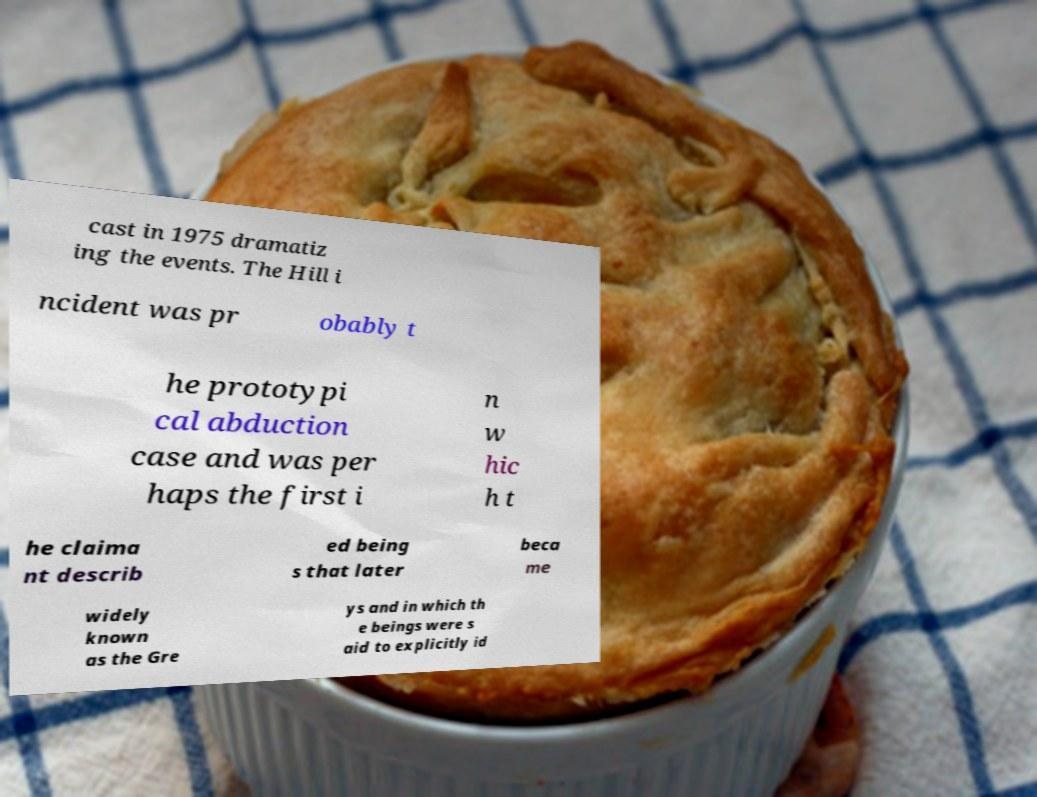Can you accurately transcribe the text from the provided image for me? cast in 1975 dramatiz ing the events. The Hill i ncident was pr obably t he prototypi cal abduction case and was per haps the first i n w hic h t he claima nt describ ed being s that later beca me widely known as the Gre ys and in which th e beings were s aid to explicitly id 